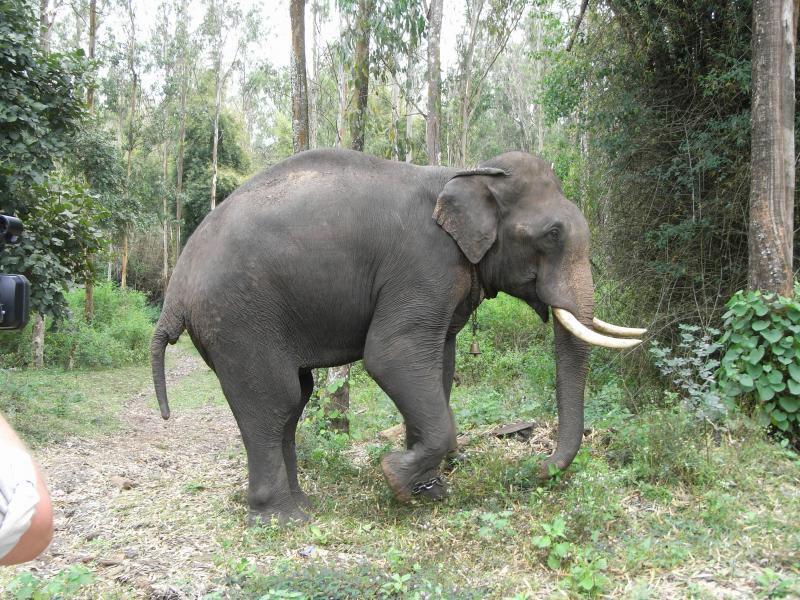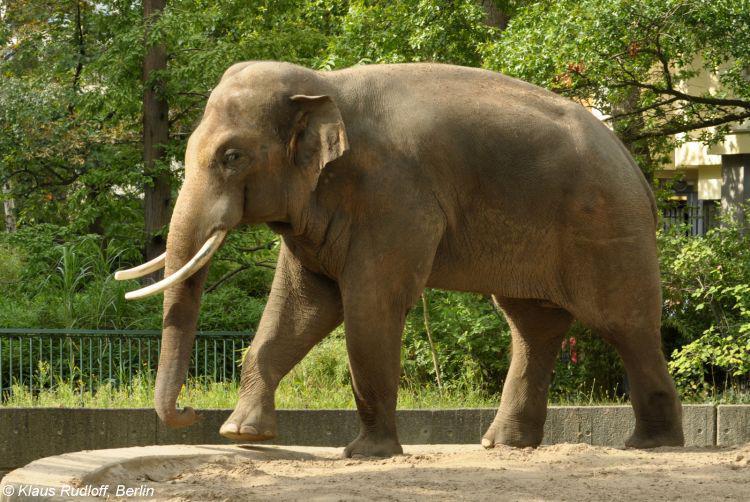The first image is the image on the left, the second image is the image on the right. For the images shown, is this caption "There is exactly one elephant facing left and exactly one elephant facing right." true? Answer yes or no. Yes. 